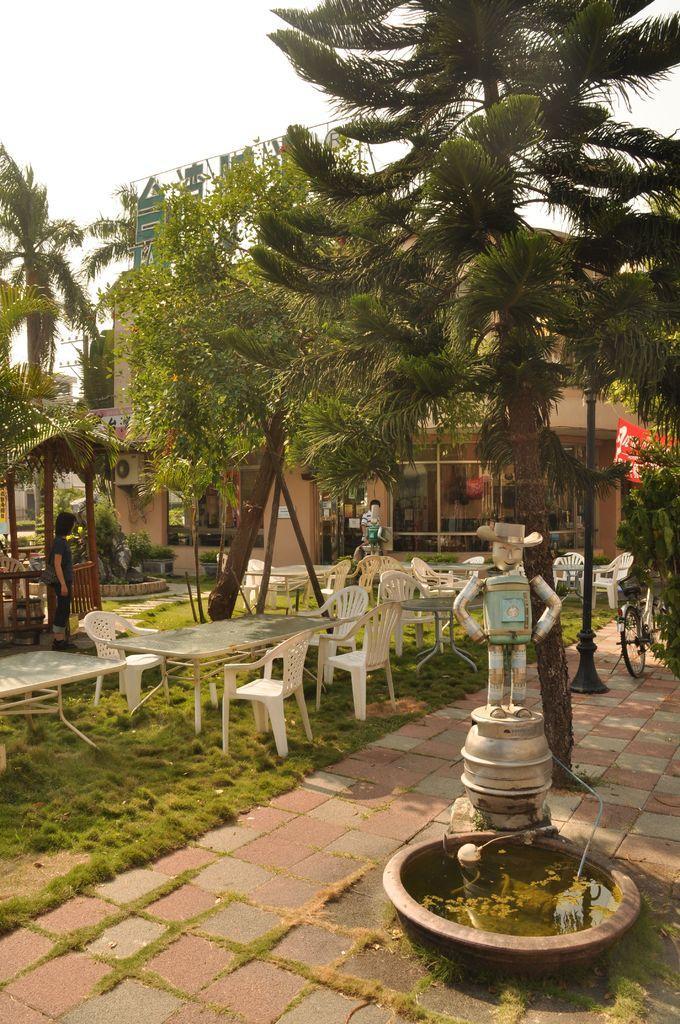Could you give a brief overview of what you see in this image? On the right side of the image we can see a fountain. On the left there are tables and chairs. We can see a lady standing. In the background there are trees and buildings. There is a pole. At the top there is sky. 